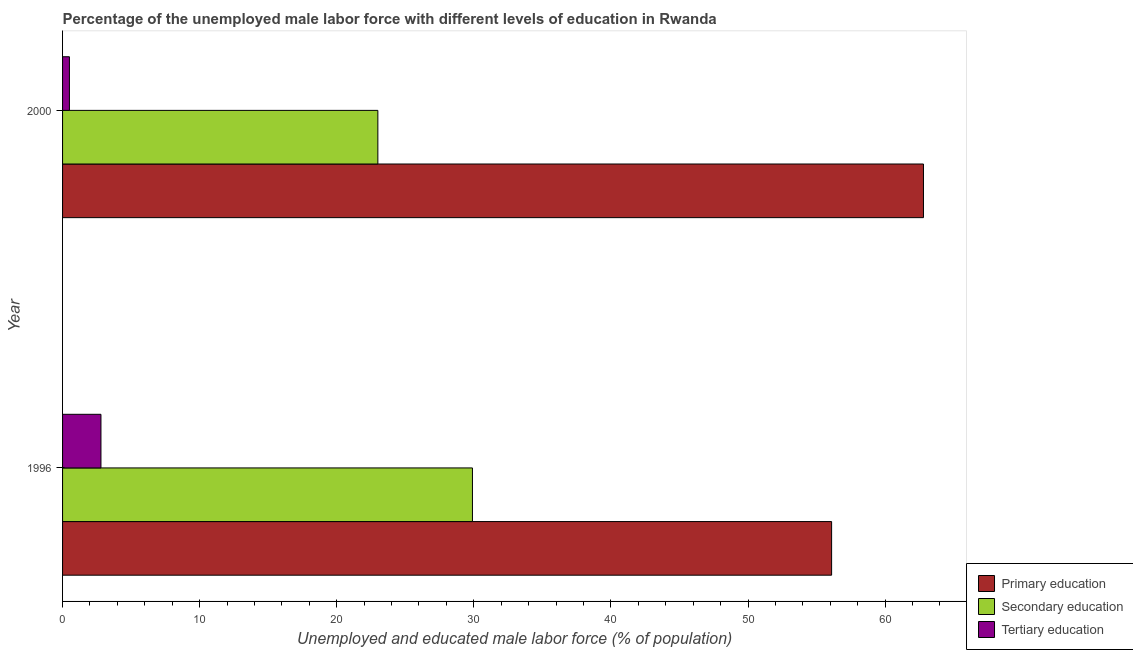How many different coloured bars are there?
Your answer should be very brief. 3. Are the number of bars per tick equal to the number of legend labels?
Provide a succinct answer. Yes. Are the number of bars on each tick of the Y-axis equal?
Make the answer very short. Yes. How many bars are there on the 1st tick from the top?
Provide a succinct answer. 3. How many bars are there on the 1st tick from the bottom?
Ensure brevity in your answer.  3. What is the label of the 1st group of bars from the top?
Your answer should be very brief. 2000. What is the percentage of male labor force who received secondary education in 1996?
Provide a short and direct response. 29.9. Across all years, what is the maximum percentage of male labor force who received primary education?
Ensure brevity in your answer.  62.8. What is the total percentage of male labor force who received primary education in the graph?
Your response must be concise. 118.9. What is the difference between the percentage of male labor force who received tertiary education in 1996 and that in 2000?
Ensure brevity in your answer.  2.3. What is the difference between the percentage of male labor force who received secondary education in 2000 and the percentage of male labor force who received primary education in 1996?
Make the answer very short. -33.1. What is the average percentage of male labor force who received primary education per year?
Give a very brief answer. 59.45. In the year 1996, what is the difference between the percentage of male labor force who received secondary education and percentage of male labor force who received primary education?
Offer a terse response. -26.2. In how many years, is the percentage of male labor force who received secondary education greater than 26 %?
Keep it short and to the point. 1. In how many years, is the percentage of male labor force who received secondary education greater than the average percentage of male labor force who received secondary education taken over all years?
Provide a succinct answer. 1. What does the 3rd bar from the top in 2000 represents?
Keep it short and to the point. Primary education. What does the 3rd bar from the bottom in 1996 represents?
Offer a very short reply. Tertiary education. Is it the case that in every year, the sum of the percentage of male labor force who received primary education and percentage of male labor force who received secondary education is greater than the percentage of male labor force who received tertiary education?
Make the answer very short. Yes. Are all the bars in the graph horizontal?
Your response must be concise. Yes. Are the values on the major ticks of X-axis written in scientific E-notation?
Your answer should be very brief. No. Does the graph contain grids?
Your answer should be very brief. No. Where does the legend appear in the graph?
Keep it short and to the point. Bottom right. How many legend labels are there?
Give a very brief answer. 3. How are the legend labels stacked?
Your response must be concise. Vertical. What is the title of the graph?
Provide a succinct answer. Percentage of the unemployed male labor force with different levels of education in Rwanda. What is the label or title of the X-axis?
Provide a succinct answer. Unemployed and educated male labor force (% of population). What is the Unemployed and educated male labor force (% of population) of Primary education in 1996?
Your answer should be compact. 56.1. What is the Unemployed and educated male labor force (% of population) of Secondary education in 1996?
Ensure brevity in your answer.  29.9. What is the Unemployed and educated male labor force (% of population) of Tertiary education in 1996?
Ensure brevity in your answer.  2.8. What is the Unemployed and educated male labor force (% of population) of Primary education in 2000?
Your answer should be very brief. 62.8. Across all years, what is the maximum Unemployed and educated male labor force (% of population) in Primary education?
Keep it short and to the point. 62.8. Across all years, what is the maximum Unemployed and educated male labor force (% of population) of Secondary education?
Ensure brevity in your answer.  29.9. Across all years, what is the maximum Unemployed and educated male labor force (% of population) of Tertiary education?
Your answer should be very brief. 2.8. Across all years, what is the minimum Unemployed and educated male labor force (% of population) of Primary education?
Give a very brief answer. 56.1. What is the total Unemployed and educated male labor force (% of population) of Primary education in the graph?
Your answer should be compact. 118.9. What is the total Unemployed and educated male labor force (% of population) in Secondary education in the graph?
Your answer should be very brief. 52.9. What is the total Unemployed and educated male labor force (% of population) of Tertiary education in the graph?
Keep it short and to the point. 3.3. What is the difference between the Unemployed and educated male labor force (% of population) of Secondary education in 1996 and that in 2000?
Provide a succinct answer. 6.9. What is the difference between the Unemployed and educated male labor force (% of population) in Primary education in 1996 and the Unemployed and educated male labor force (% of population) in Secondary education in 2000?
Your response must be concise. 33.1. What is the difference between the Unemployed and educated male labor force (% of population) in Primary education in 1996 and the Unemployed and educated male labor force (% of population) in Tertiary education in 2000?
Your answer should be very brief. 55.6. What is the difference between the Unemployed and educated male labor force (% of population) in Secondary education in 1996 and the Unemployed and educated male labor force (% of population) in Tertiary education in 2000?
Give a very brief answer. 29.4. What is the average Unemployed and educated male labor force (% of population) in Primary education per year?
Provide a short and direct response. 59.45. What is the average Unemployed and educated male labor force (% of population) of Secondary education per year?
Offer a terse response. 26.45. What is the average Unemployed and educated male labor force (% of population) in Tertiary education per year?
Your answer should be very brief. 1.65. In the year 1996, what is the difference between the Unemployed and educated male labor force (% of population) of Primary education and Unemployed and educated male labor force (% of population) of Secondary education?
Offer a very short reply. 26.2. In the year 1996, what is the difference between the Unemployed and educated male labor force (% of population) in Primary education and Unemployed and educated male labor force (% of population) in Tertiary education?
Ensure brevity in your answer.  53.3. In the year 1996, what is the difference between the Unemployed and educated male labor force (% of population) in Secondary education and Unemployed and educated male labor force (% of population) in Tertiary education?
Ensure brevity in your answer.  27.1. In the year 2000, what is the difference between the Unemployed and educated male labor force (% of population) of Primary education and Unemployed and educated male labor force (% of population) of Secondary education?
Give a very brief answer. 39.8. In the year 2000, what is the difference between the Unemployed and educated male labor force (% of population) of Primary education and Unemployed and educated male labor force (% of population) of Tertiary education?
Give a very brief answer. 62.3. In the year 2000, what is the difference between the Unemployed and educated male labor force (% of population) in Secondary education and Unemployed and educated male labor force (% of population) in Tertiary education?
Ensure brevity in your answer.  22.5. What is the ratio of the Unemployed and educated male labor force (% of population) of Primary education in 1996 to that in 2000?
Make the answer very short. 0.89. What is the ratio of the Unemployed and educated male labor force (% of population) in Tertiary education in 1996 to that in 2000?
Provide a short and direct response. 5.6. What is the difference between the highest and the lowest Unemployed and educated male labor force (% of population) of Tertiary education?
Offer a terse response. 2.3. 